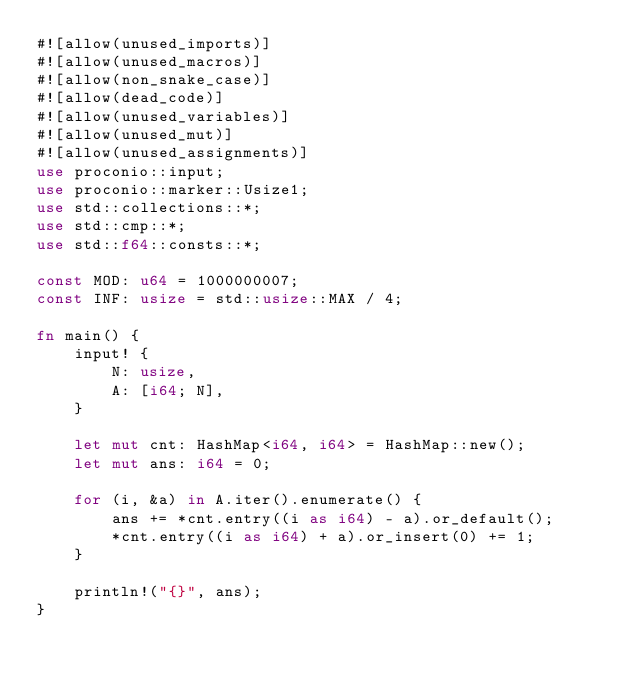Convert code to text. <code><loc_0><loc_0><loc_500><loc_500><_Rust_>#![allow(unused_imports)]
#![allow(unused_macros)]
#![allow(non_snake_case)]
#![allow(dead_code)]
#![allow(unused_variables)]
#![allow(unused_mut)]
#![allow(unused_assignments)]
use proconio::input;
use proconio::marker::Usize1;
use std::collections::*;
use std::cmp::*;
use std::f64::consts::*;

const MOD: u64 = 1000000007;
const INF: usize = std::usize::MAX / 4;

fn main() {
    input! {
        N: usize,
        A: [i64; N],
    }

    let mut cnt: HashMap<i64, i64> = HashMap::new();
    let mut ans: i64 = 0;

    for (i, &a) in A.iter().enumerate() {
        ans += *cnt.entry((i as i64) - a).or_default();
        *cnt.entry((i as i64) + a).or_insert(0) += 1;
    }

    println!("{}", ans);
}
</code> 